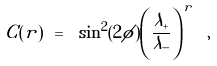<formula> <loc_0><loc_0><loc_500><loc_500>C ( r ) \ = \ \sin ^ { 2 } ( 2 \phi ) \left ( \frac { \lambda _ { + } } { \lambda _ { - } } \right ) ^ { r } \ ,</formula> 